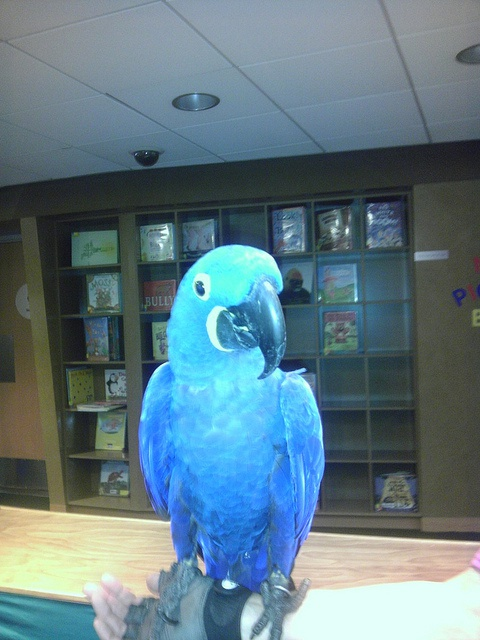Describe the objects in this image and their specific colors. I can see bird in gray, lightblue, and blue tones, people in gray, ivory, blue, and darkgray tones, book in gray, black, purple, and darkblue tones, book in gray, blue, and navy tones, and book in gray, teal, and darkgreen tones in this image. 